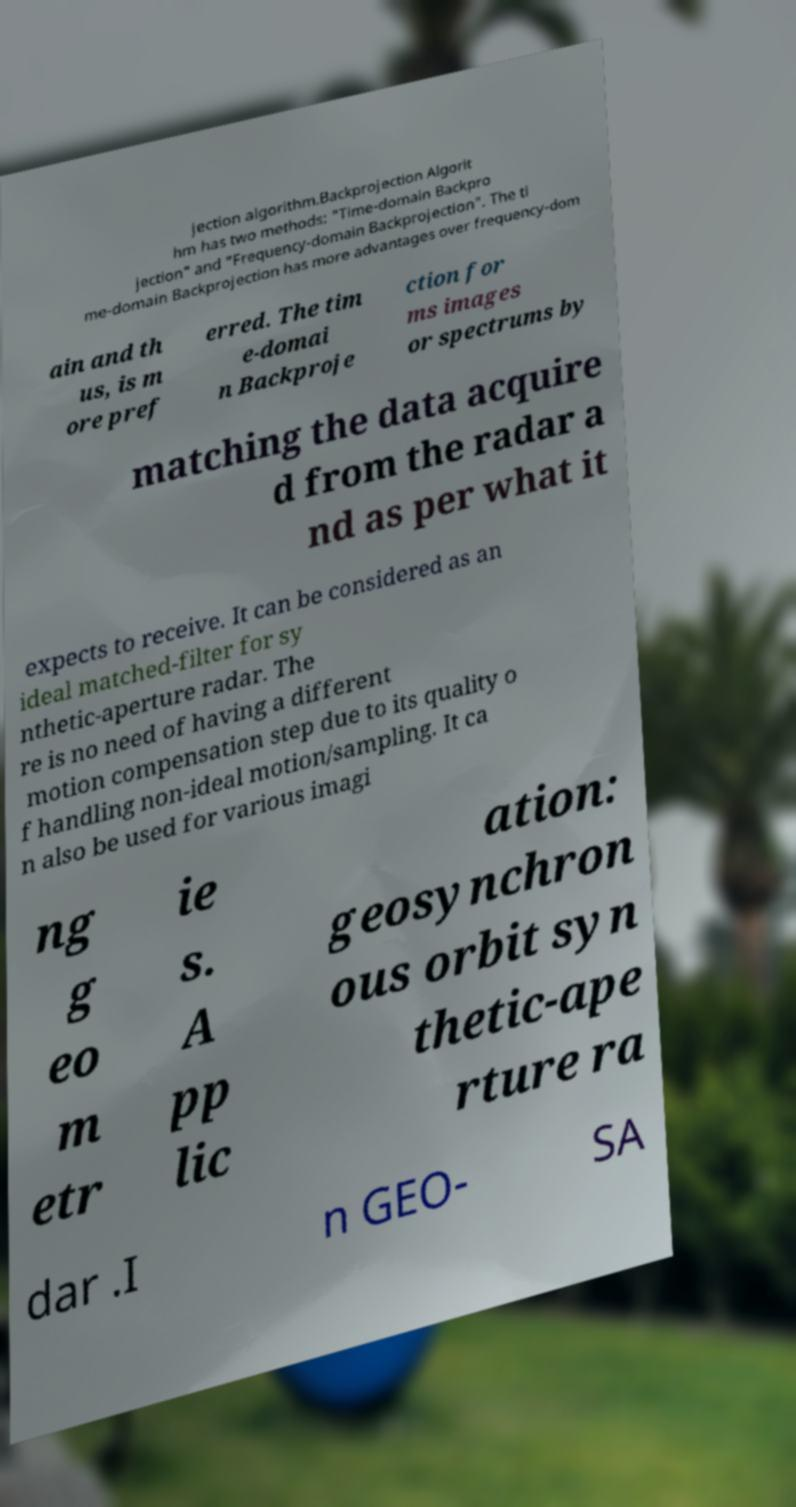Can you read and provide the text displayed in the image?This photo seems to have some interesting text. Can you extract and type it out for me? jection algorithm.Backprojection Algorit hm has two methods: "Time-domain Backpro jection" and "Frequency-domain Backprojection". The ti me-domain Backprojection has more advantages over frequency-dom ain and th us, is m ore pref erred. The tim e-domai n Backproje ction for ms images or spectrums by matching the data acquire d from the radar a nd as per what it expects to receive. It can be considered as an ideal matched-filter for sy nthetic-aperture radar. The re is no need of having a different motion compensation step due to its quality o f handling non-ideal motion/sampling. It ca n also be used for various imagi ng g eo m etr ie s. A pp lic ation: geosynchron ous orbit syn thetic-ape rture ra dar .I n GEO- SA 